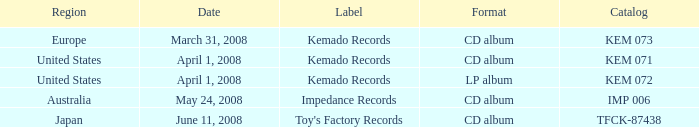Which Format has a Date of may 24, 2008? CD album. 